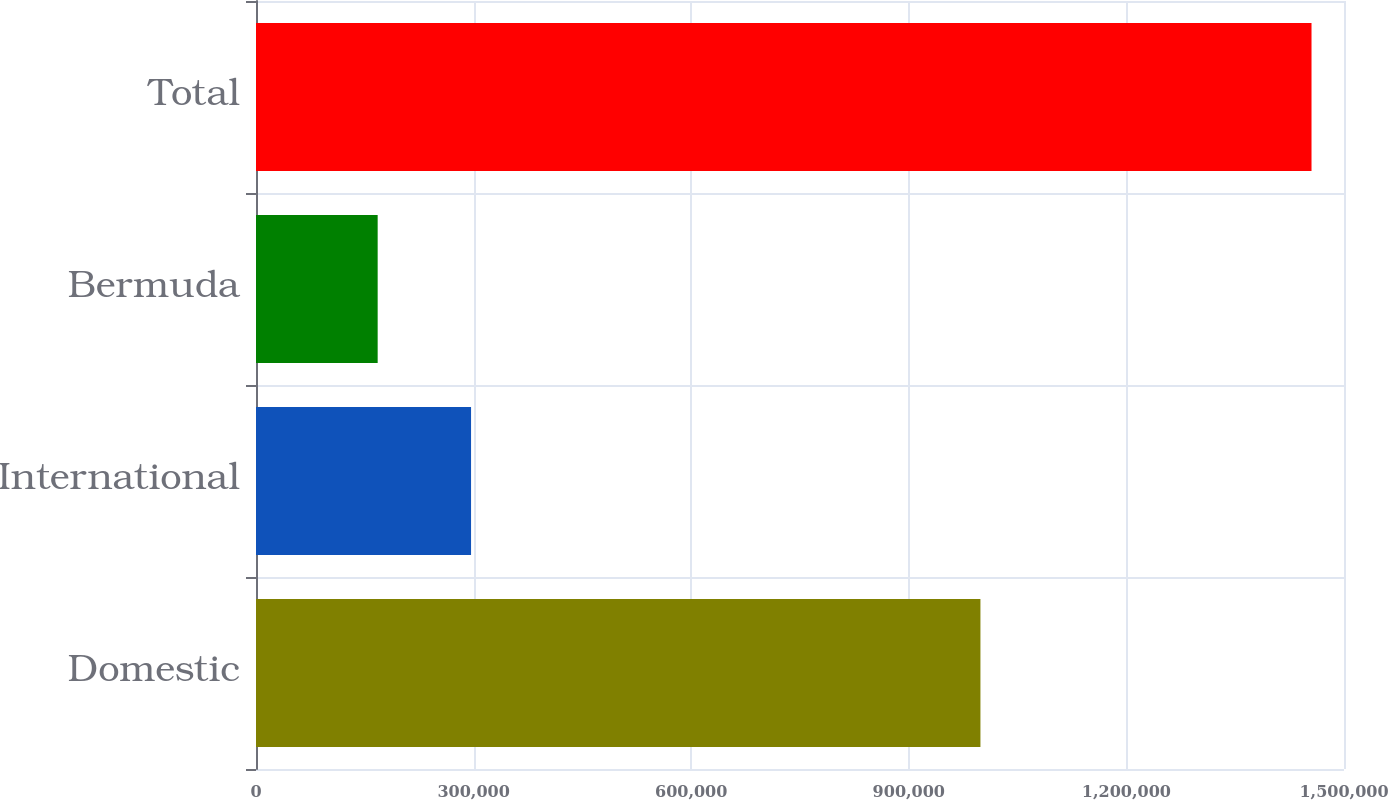Convert chart to OTSL. <chart><loc_0><loc_0><loc_500><loc_500><bar_chart><fcel>Domestic<fcel>International<fcel>Bermuda<fcel>Total<nl><fcel>998755<fcel>296491<fcel>167743<fcel>1.45522e+06<nl></chart> 